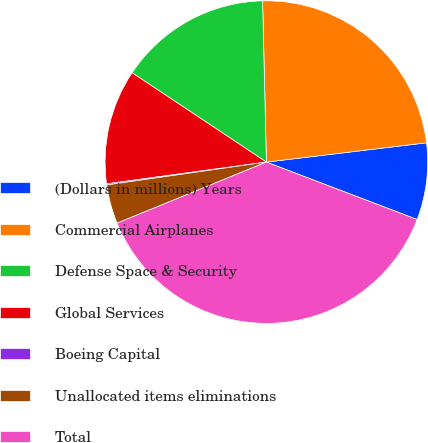<chart> <loc_0><loc_0><loc_500><loc_500><pie_chart><fcel>(Dollars in millions) Years<fcel>Commercial Airplanes<fcel>Defense Space & Security<fcel>Global Services<fcel>Boeing Capital<fcel>Unallocated items eliminations<fcel>Total<nl><fcel>7.7%<fcel>23.46%<fcel>15.28%<fcel>11.49%<fcel>0.12%<fcel>3.91%<fcel>38.02%<nl></chart> 